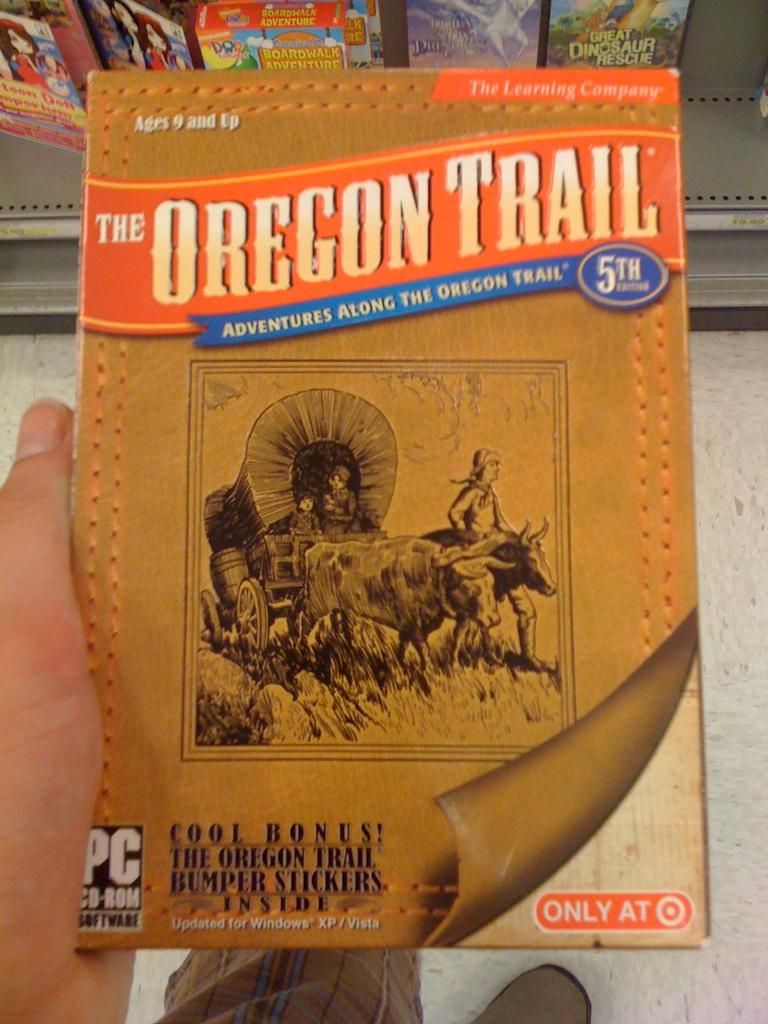<image>
Render a clear and concise summary of the photo. A CD for PC that is titled The Oregon Trail. 